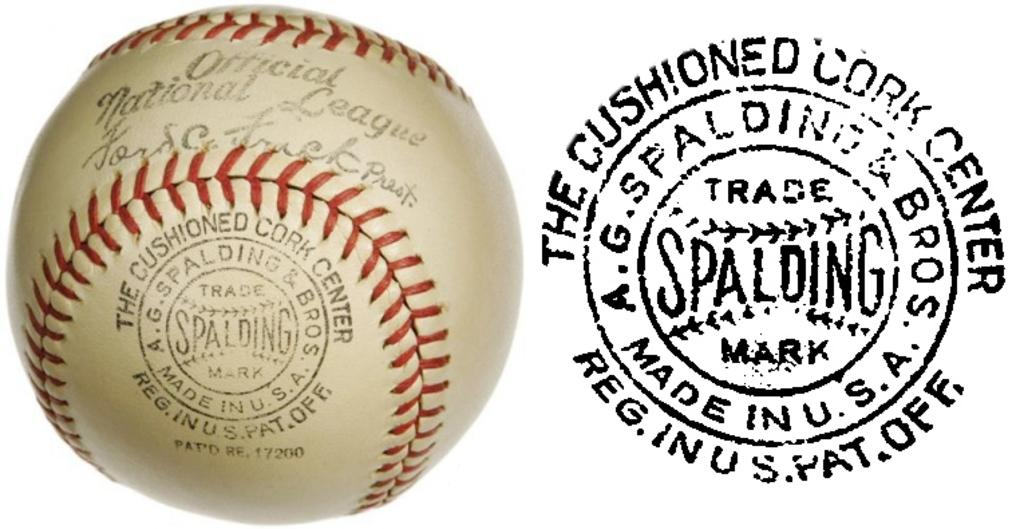<image>
Present a compact description of the photo's key features. a close up of a baseball with words Spalding on it 